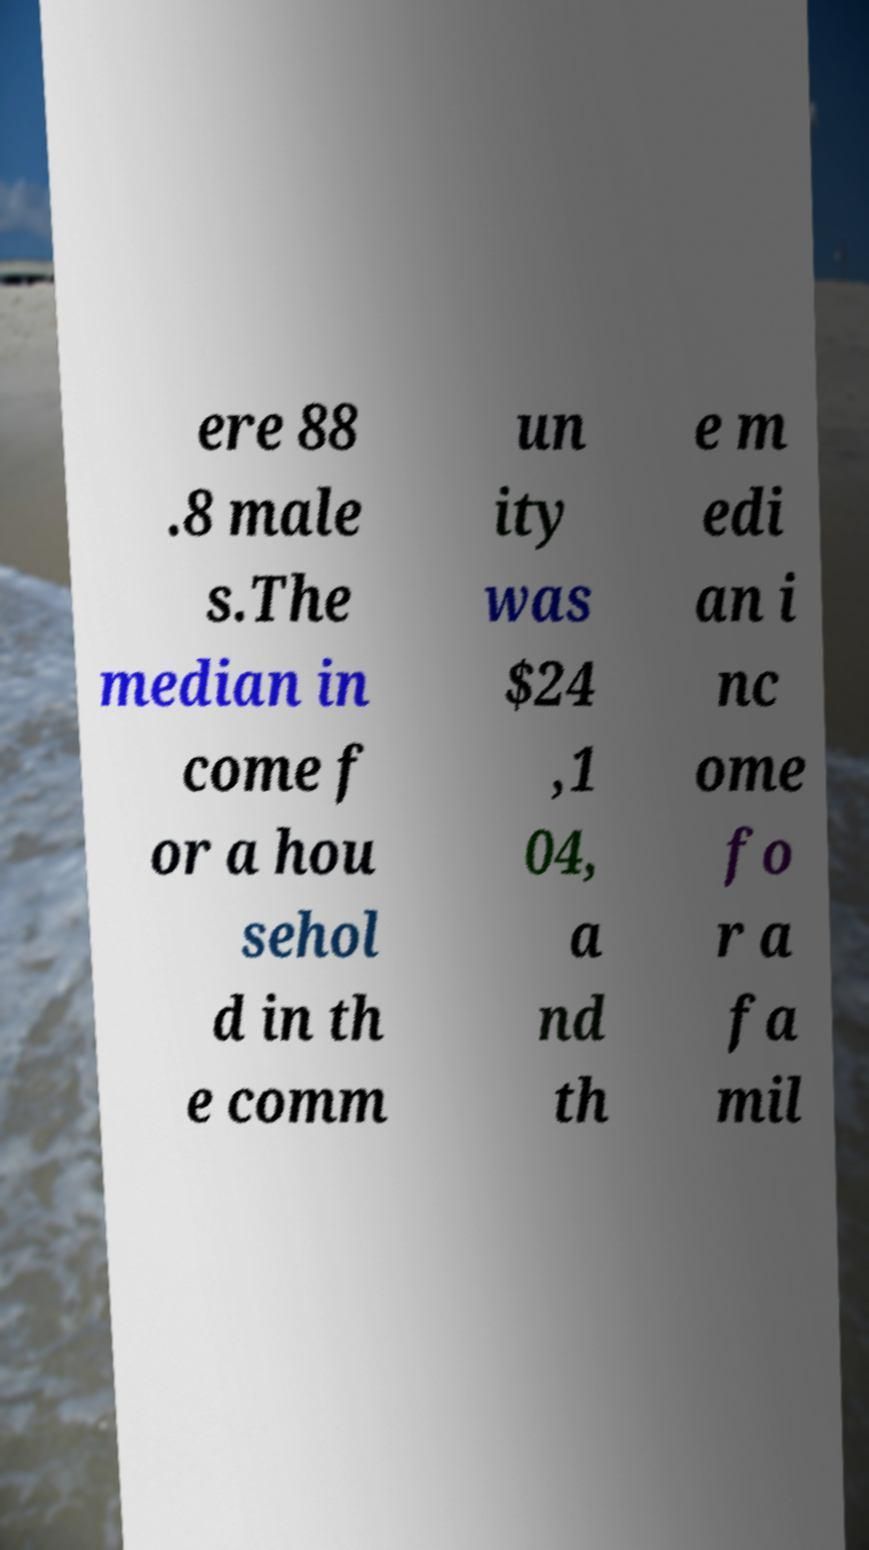For documentation purposes, I need the text within this image transcribed. Could you provide that? ere 88 .8 male s.The median in come f or a hou sehol d in th e comm un ity was $24 ,1 04, a nd th e m edi an i nc ome fo r a fa mil 